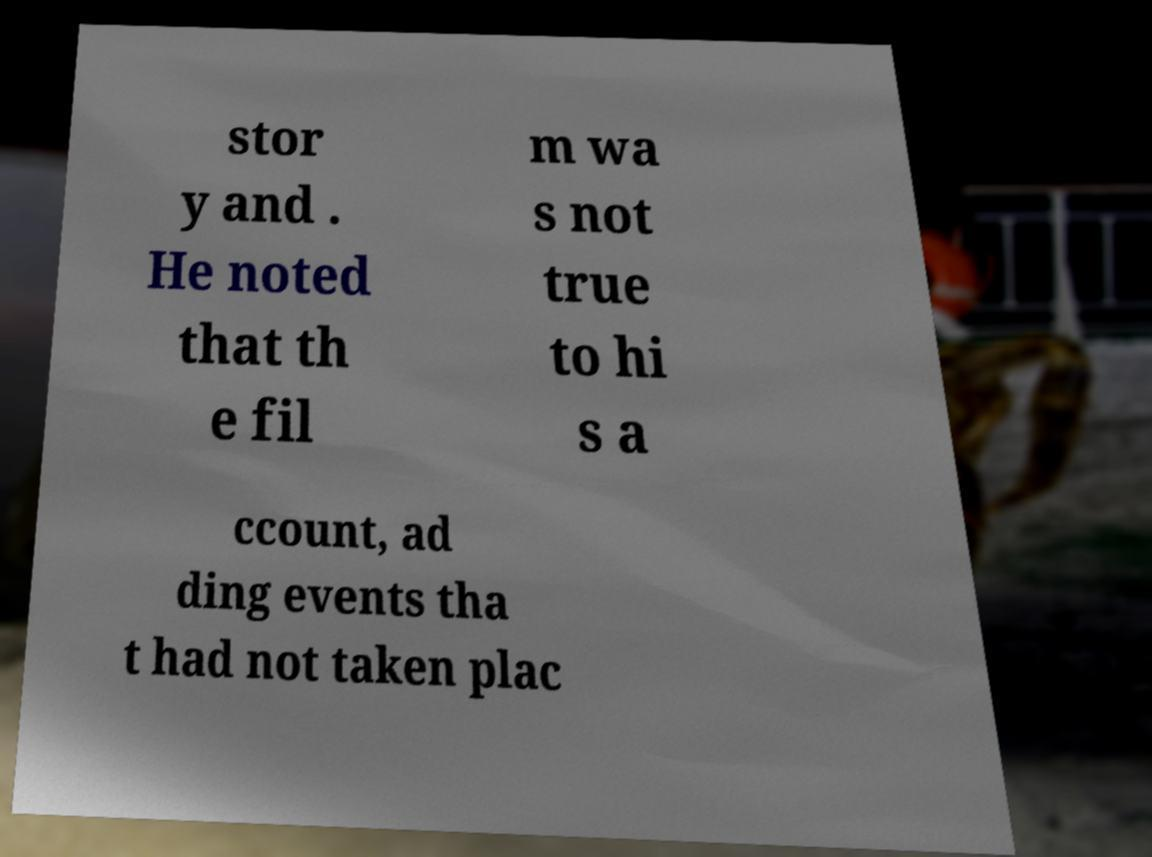What messages or text are displayed in this image? I need them in a readable, typed format. stor y and . He noted that th e fil m wa s not true to hi s a ccount, ad ding events tha t had not taken plac 